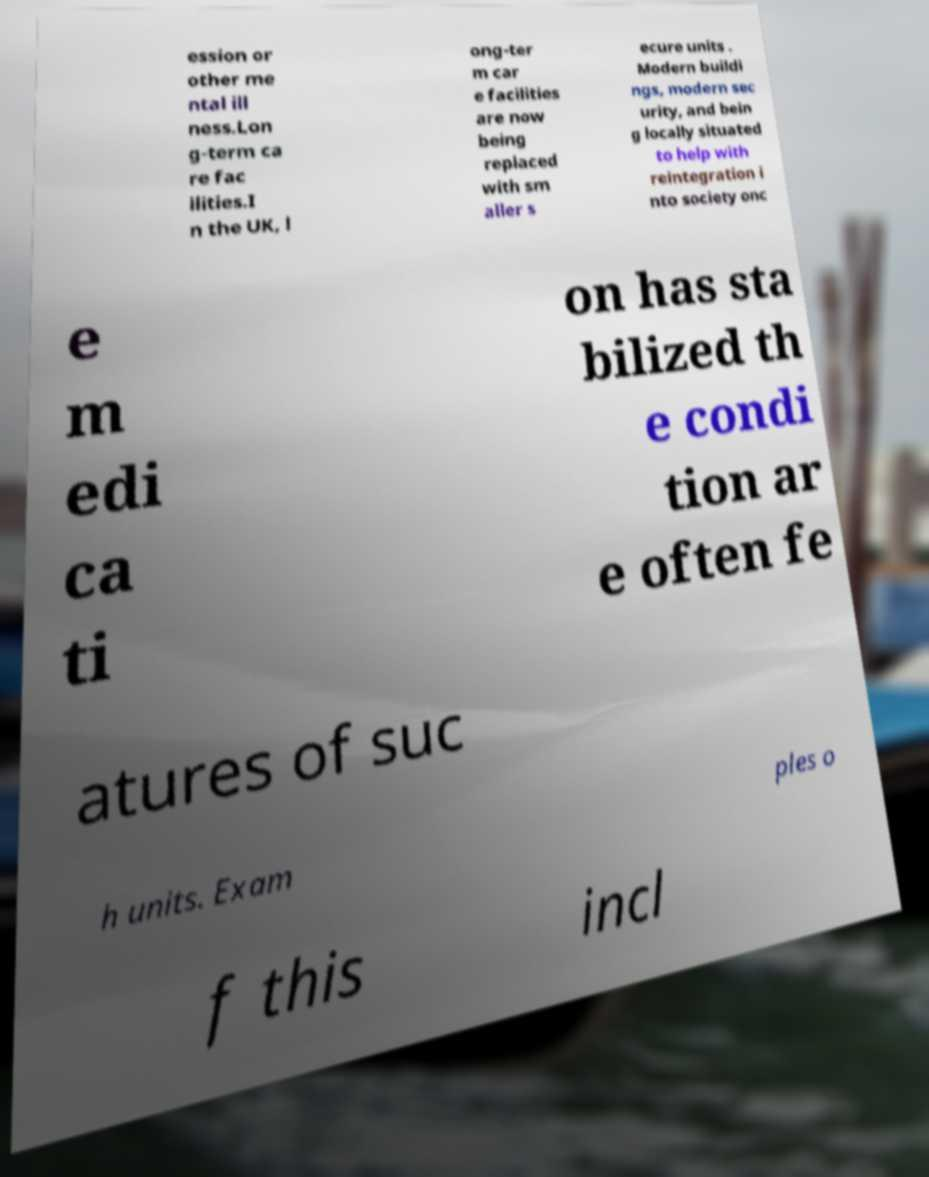Please identify and transcribe the text found in this image. ession or other me ntal ill ness.Lon g-term ca re fac ilities.I n the UK, l ong-ter m car e facilities are now being replaced with sm aller s ecure units . Modern buildi ngs, modern sec urity, and bein g locally situated to help with reintegration i nto society onc e m edi ca ti on has sta bilized th e condi tion ar e often fe atures of suc h units. Exam ples o f this incl 